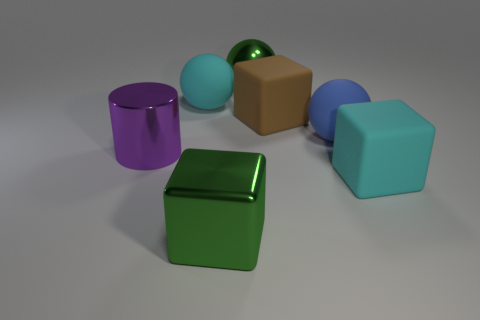In terms of size, how does the green object compare with the purple cylinder? The green object, which appears to be a cube, is smaller in size when compared to the purple cylinder beside it. The cylinder looks taller and has a wider diameter, therefore occupying more space visually. 